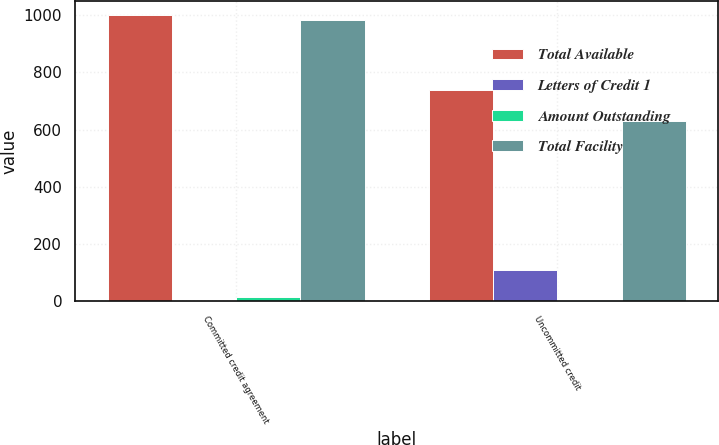<chart> <loc_0><loc_0><loc_500><loc_500><stacked_bar_chart><ecel><fcel>Committed credit agreement<fcel>Uncommitted credit<nl><fcel>Total Available<fcel>1000<fcel>740.3<nl><fcel>Letters of Credit 1<fcel>0<fcel>107.2<nl><fcel>Amount Outstanding<fcel>16<fcel>3.9<nl><fcel>Total Facility<fcel>984<fcel>629.2<nl></chart> 